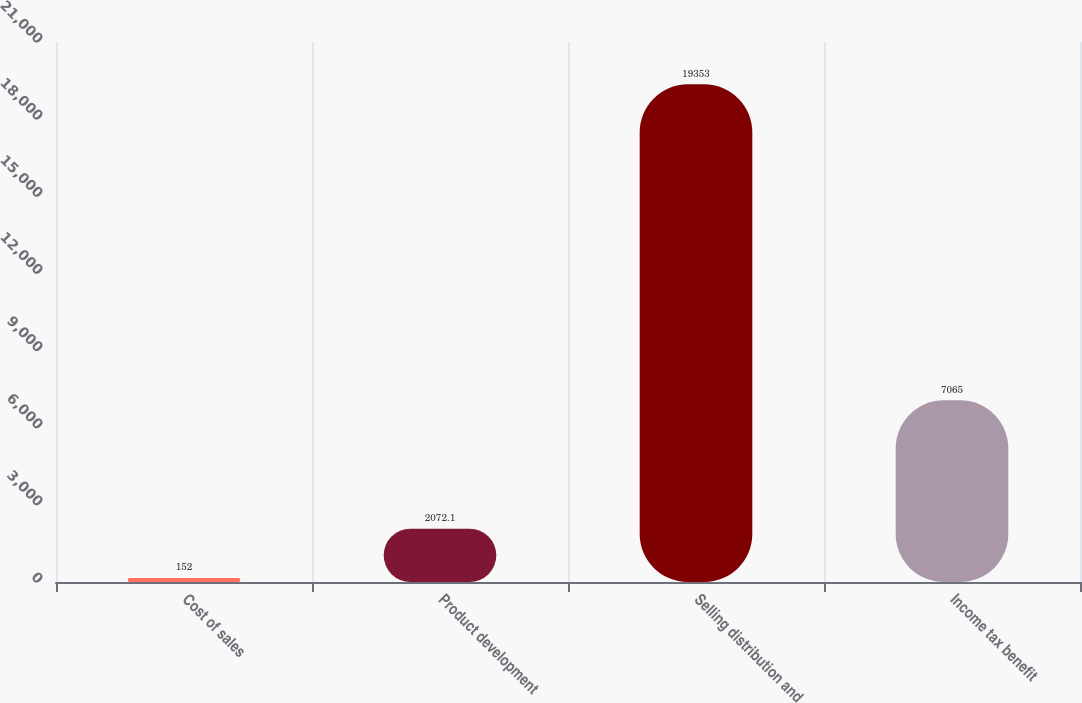<chart> <loc_0><loc_0><loc_500><loc_500><bar_chart><fcel>Cost of sales<fcel>Product development<fcel>Selling distribution and<fcel>Income tax benefit<nl><fcel>152<fcel>2072.1<fcel>19353<fcel>7065<nl></chart> 